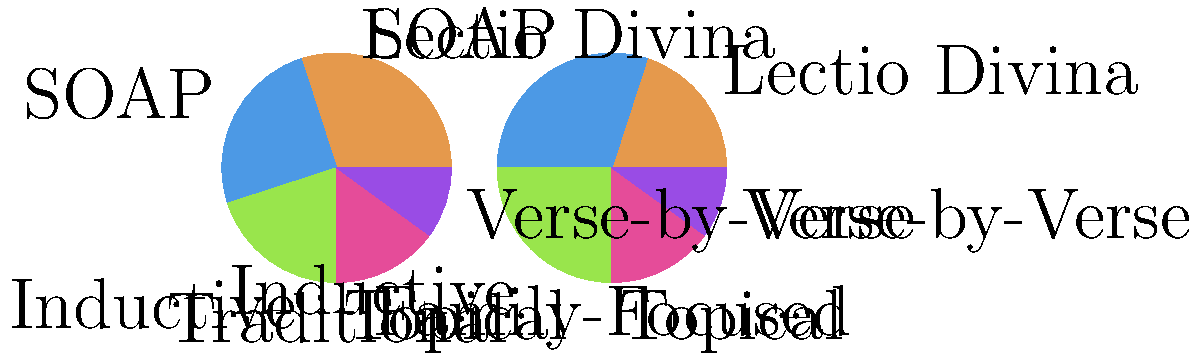Based on the pie charts comparing traditional and family-focused Bible study methods, which method shows the greatest increase in usage when adapted for family-focused study? To determine which Bible study method shows the greatest increase in usage when adapted for family-focused study, we need to compare the percentages for each method between the two pie charts:

1. Lectio Divina:
   Traditional: 30%, Family-Focused: 20%
   Change: -10%

2. SOAP (Scripture, Observation, Application, Prayer):
   Traditional: 25%, Family-Focused: 30%
   Change: +5%

3. Inductive:
   Traditional: 20%, Family-Focused: 25%
   Change: +5%

4. Topical:
   Traditional: 15%, Family-Focused: 15%
   Change: 0%

5. Verse-by-Verse:
   Traditional: 10%, Family-Focused: 10%
   Change: 0%

The SOAP method and the Inductive method both show an increase of 5%, which is the largest positive change among all methods. However, the SOAP method has a higher overall percentage in the family-focused chart (30% compared to 25% for Inductive), indicating a slightly more significant shift towards this method in family-focused study.
Answer: SOAP (Scripture, Observation, Application, Prayer) 